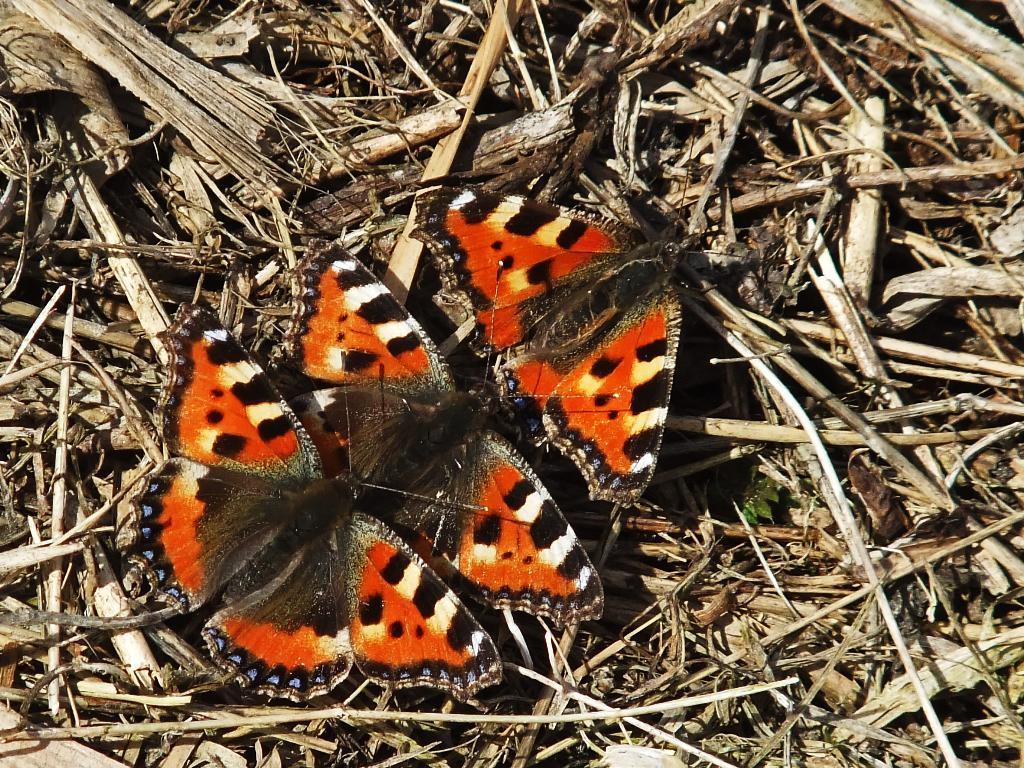Could you give a brief overview of what you see in this image? In this image there are three butterflies on dry wooden sticks. 